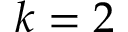<formula> <loc_0><loc_0><loc_500><loc_500>k = 2</formula> 